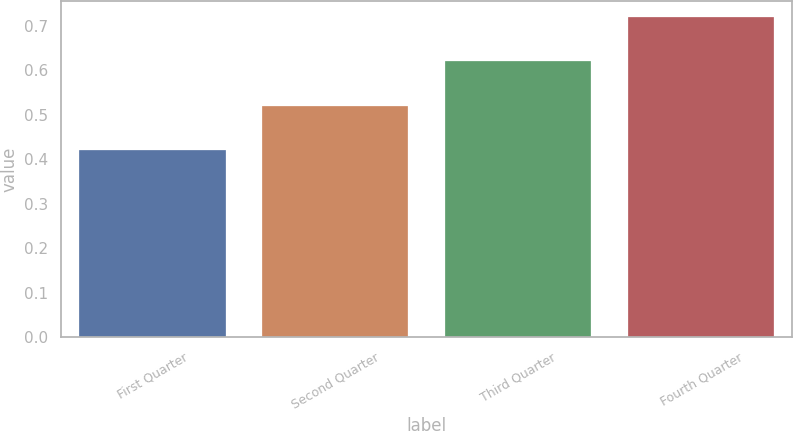<chart> <loc_0><loc_0><loc_500><loc_500><bar_chart><fcel>First Quarter<fcel>Second Quarter<fcel>Third Quarter<fcel>Fourth Quarter<nl><fcel>0.42<fcel>0.52<fcel>0.62<fcel>0.72<nl></chart> 